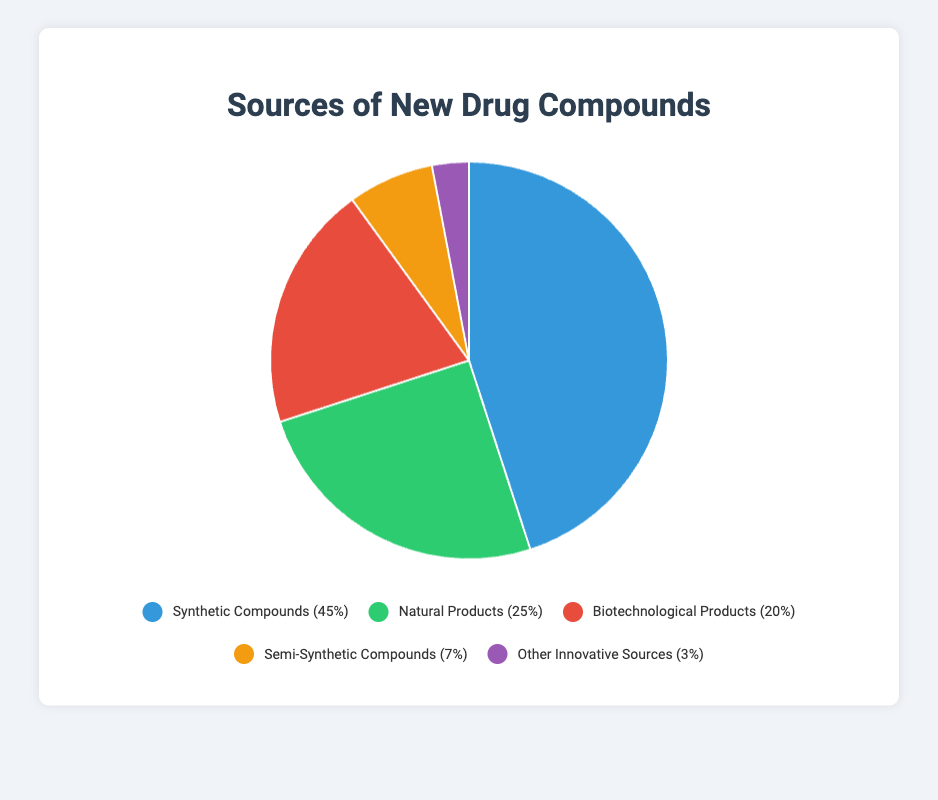What percentage of the sources of new drug compounds are synthetic or natural? To calculate the combined percentage of synthetic and natural products, add the percentages for both segments (Synthetic Compounds: 45% + Natural Products: 25%).
Answer: 70% How many times greater is the percentage of synthetic compounds compared to other innovative sources? Divide the percentage of synthetic compounds (45%) by the percentage of other innovative sources (3%). 45 / 3 = 15.
Answer: 15 times Which segment has the second highest percentage? Refer to the data points and identify the segment with the second highest value: Synthetic Compounds (45%), Natural Products (25%), Biotechnological Products (20%), Semi-Synthetic Compounds (7%), Other Innovative Sources (3%). The segment with the second highest value is Natural Products.
Answer: Natural Products If we combine the percentages of semi-synthetic and biotechnological products, how does this combined percentage compare to that of natural products? Add the percentages of semi-synthetic (7%) and biotechnological products (20%) to get 27%. Compare this with the percentage of natural products (25%). 27% is slightly higher than 25%.
Answer: Higher What is the visual color representation of biotechnological products in the pie chart? Look at the segment representing Biotechnological Products and identify its color from the chart. Biotechnological Products are represented by the red segment.
Answer: Red Which segment occupies the smallest percentage on the pie chart, and what are the examples of this segment? Identify the segment with the smallest percentage: Synthetic Compounds (45%), Natural Products (25%), Biotechnological Products (20%), Semi-Synthetic Compounds (7%), Other Innovative Sources (3%). The segment with the smallest percentage is Other Innovative Sources. Examples are Gene Therapy Drugs and CAR-T Cell Therapy.
Answer: Other Innovative Sources (Gene Therapy Drugs, CAR-T Cell Therapy) How does the percentage of synthetic compounds compare to the combined percentage of biotechnological, semi-synthetic, and other innovative sources? Sum the percentages of biotechnological (20%), semi-synthetic (7%), and other innovative sources (3%): 20% + 7% + 3% = 30%. Compare this to synthetic compounds (45%). Synthetic compounds have a higher percentage.
Answer: Higher What is the combined percentage of biotechnological and other innovative sources, and what is one example from each? Add the percentages of biotechnological (20%) and other innovative sources (3%) to get 23%. Examples include Insulin (biotechnological) and Gene Therapy Drugs (innovative sources).
Answer: 23%, Insulin and Gene Therapy Drugs 